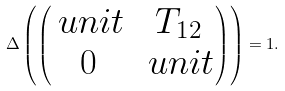<formula> <loc_0><loc_0><loc_500><loc_500>\Delta \left ( \begin{pmatrix} \ u n i t & T _ { 1 2 } \\ 0 & \ u n i t \end{pmatrix} \right ) = 1 .</formula> 